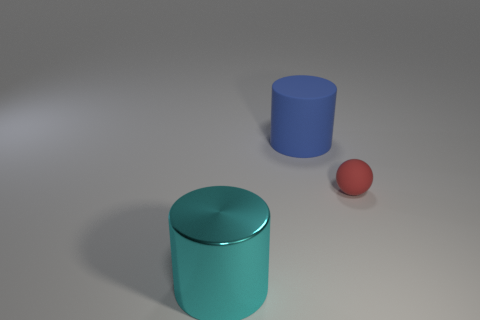Add 3 small blue rubber spheres. How many objects exist? 6 Subtract all cylinders. How many objects are left? 1 Subtract all big blue cylinders. Subtract all shiny objects. How many objects are left? 1 Add 1 large cylinders. How many large cylinders are left? 3 Add 3 brown matte cylinders. How many brown matte cylinders exist? 3 Subtract 0 green cylinders. How many objects are left? 3 